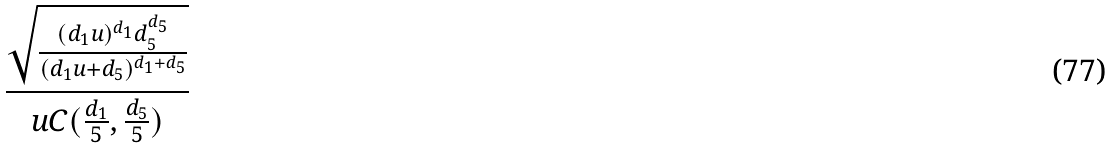Convert formula to latex. <formula><loc_0><loc_0><loc_500><loc_500>\frac { \sqrt { \frac { ( d _ { 1 } u ) ^ { d _ { 1 } } d _ { 5 } ^ { d _ { 5 } } } { ( d _ { 1 } u + d _ { 5 } ) ^ { d _ { 1 } + d _ { 5 } } } } } { u C ( \frac { d _ { 1 } } { 5 } , \frac { d _ { 5 } } { 5 } ) }</formula> 